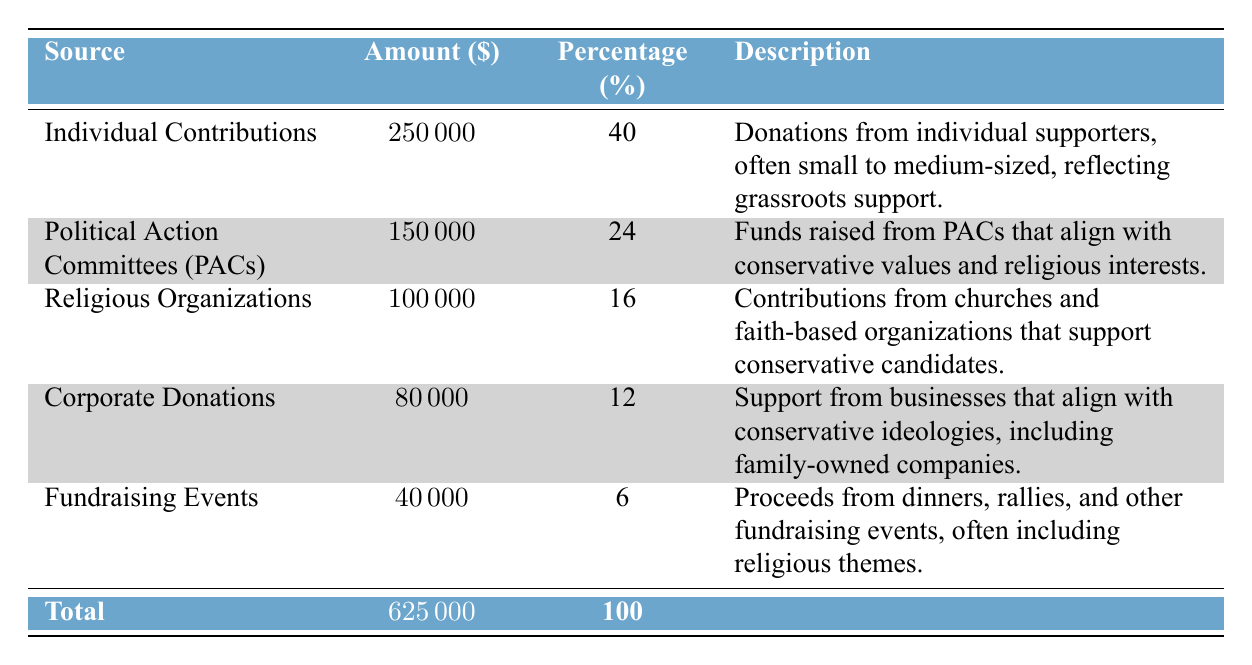What is the total amount of fundraising contributions? The total amount is explicitly listed in the last row of the table, which states that the total is 625000.
Answer: 625000 What percentage of the total contributions comes from Individual Contributions? The percentage for Individual Contributions is shown in the table as 40%.
Answer: 40% Is the amount from Political Action Committees greater than the amount from Corporate Donations? The amount from Political Action Committees is 150000, while the amount from Corporate Donations is 80000. Since 150000 is greater than 80000, the statement is true.
Answer: Yes What is the combined amount of contributions from Religious Organizations and Fundraising Events? The amount from Religious Organizations is 100000, and the amount from Fundraising Events is 40000. Adding these two gives 100000 + 40000 = 140000.
Answer: 140000 Does the sum of contributions from Individual Contributions and Corporate Donations exceed 300000? The amount from Individual Contributions is 250000, and from Corporate Donations is 80000. Summing these gives 250000 + 80000 = 330000, which exceeds 300000. Therefore, the statement is true.
Answer: Yes What is the average contribution amount from the five sources listed? To find the average, sum the amounts from all sources: 250000 + 150000 + 100000 + 80000 + 40000 = 625000, and then divide by the number of sources (5): 625000 / 5 = 125000.
Answer: 125000 Which source has the least amount of contributions and what is that amount? The source with the least amount listed in the table is Fundraising Events, with an amount of 40000.
Answer: Fundraising Events, 40000 What percentage of the total fundraising contributions comes from Religious Organizations? The percentage of contributions from Religious Organizations is listed as 16% in the table.
Answer: 16% Which type of contribution provides the highest amount, and how much is it? According to the table, Individual Contributions provide the highest amount at 250000.
Answer: Individual Contributions, 250000 